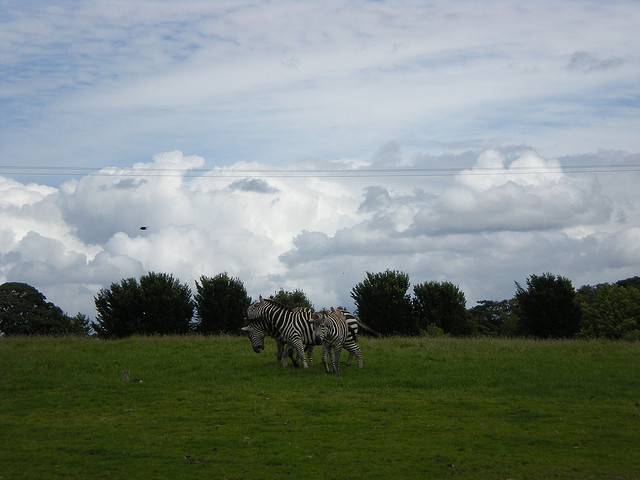<image>Where is the fence? The fence is not visible in the image. Where is the fence? I don't know where the fence is. It can be your best guess. 